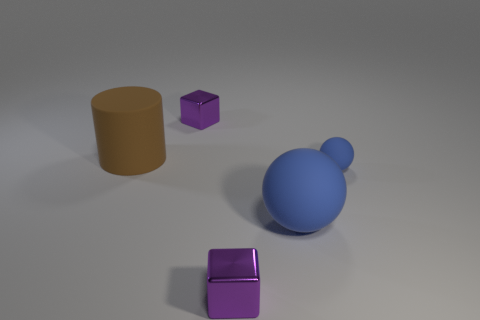Add 1 green metal things. How many objects exist? 6 Add 5 small blue cylinders. How many small blue cylinders exist? 5 Subtract 0 gray spheres. How many objects are left? 5 Subtract all cylinders. How many objects are left? 4 Subtract all blue cylinders. Subtract all purple spheres. How many cylinders are left? 1 Subtract all small metallic cubes. Subtract all big brown cylinders. How many objects are left? 2 Add 3 big matte things. How many big matte things are left? 5 